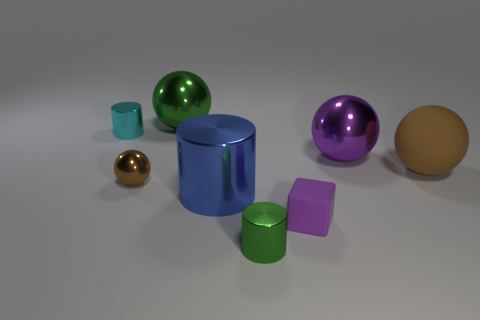Add 1 purple blocks. How many objects exist? 9 Subtract all cubes. How many objects are left? 7 Add 3 big matte cylinders. How many big matte cylinders exist? 3 Subtract 1 purple cubes. How many objects are left? 7 Subtract all purple cubes. Subtract all large things. How many objects are left? 3 Add 6 cyan metallic things. How many cyan metallic things are left? 7 